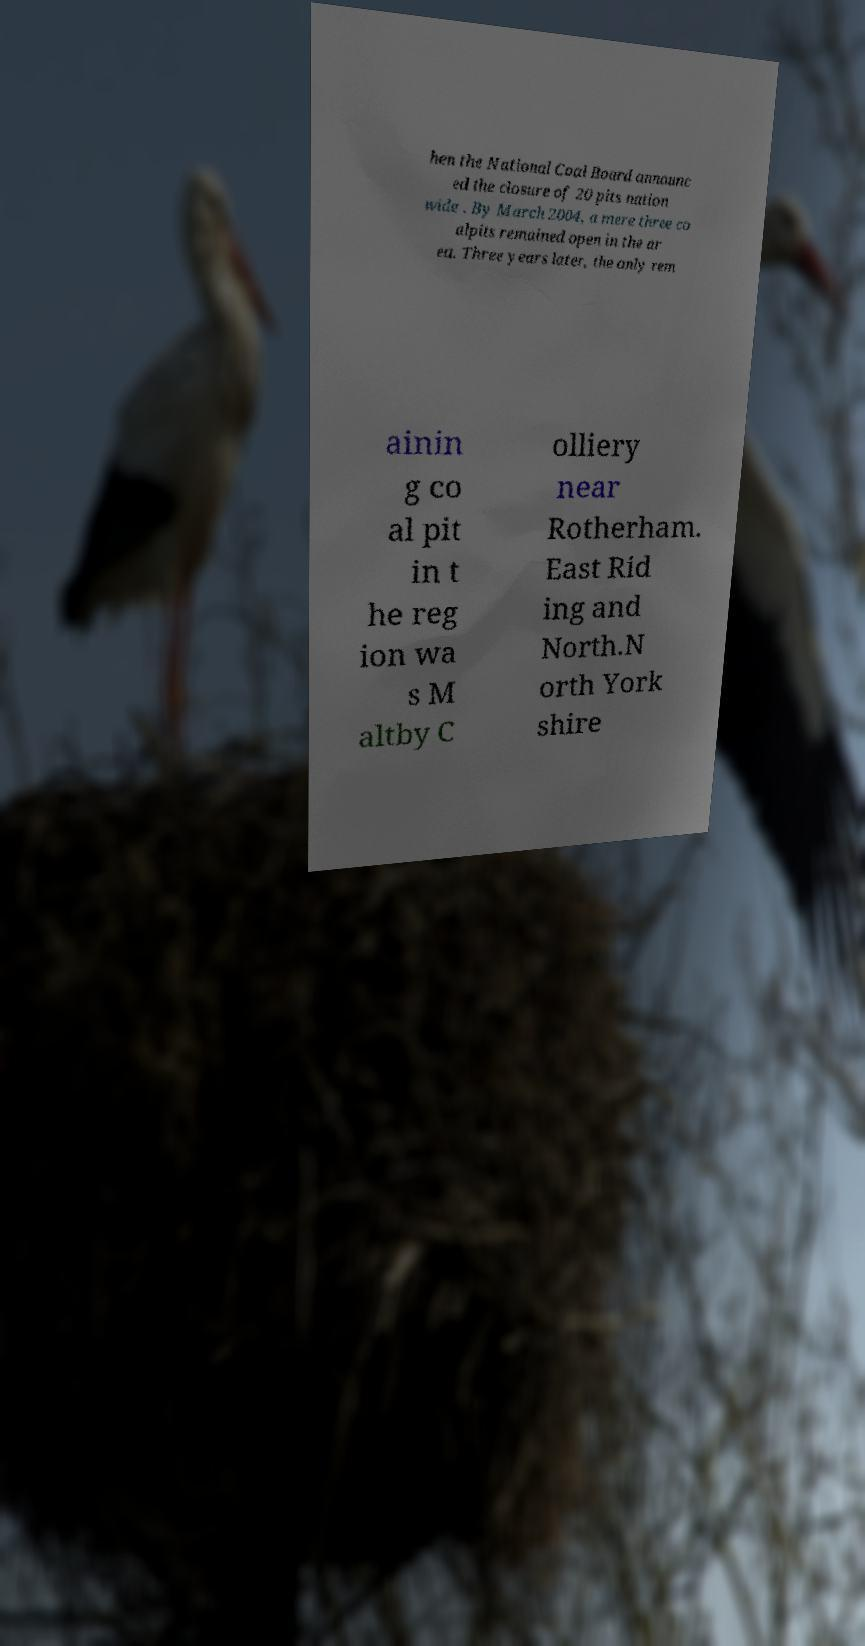Could you extract and type out the text from this image? hen the National Coal Board announc ed the closure of 20 pits nation wide . By March 2004, a mere three co alpits remained open in the ar ea. Three years later, the only rem ainin g co al pit in t he reg ion wa s M altby C olliery near Rotherham. East Rid ing and North.N orth York shire 